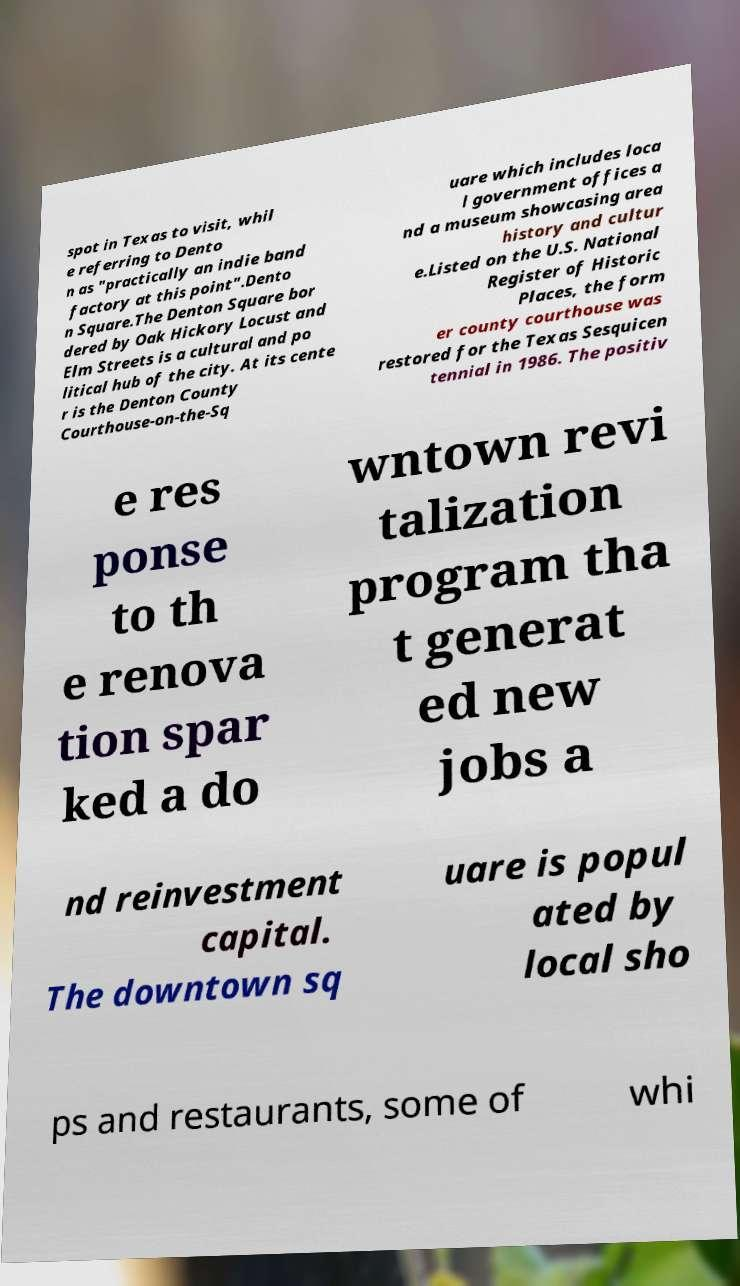Please read and relay the text visible in this image. What does it say? spot in Texas to visit, whil e referring to Dento n as "practically an indie band factory at this point".Dento n Square.The Denton Square bor dered by Oak Hickory Locust and Elm Streets is a cultural and po litical hub of the city. At its cente r is the Denton County Courthouse-on-the-Sq uare which includes loca l government offices a nd a museum showcasing area history and cultur e.Listed on the U.S. National Register of Historic Places, the form er county courthouse was restored for the Texas Sesquicen tennial in 1986. The positiv e res ponse to th e renova tion spar ked a do wntown revi talization program tha t generat ed new jobs a nd reinvestment capital. The downtown sq uare is popul ated by local sho ps and restaurants, some of whi 